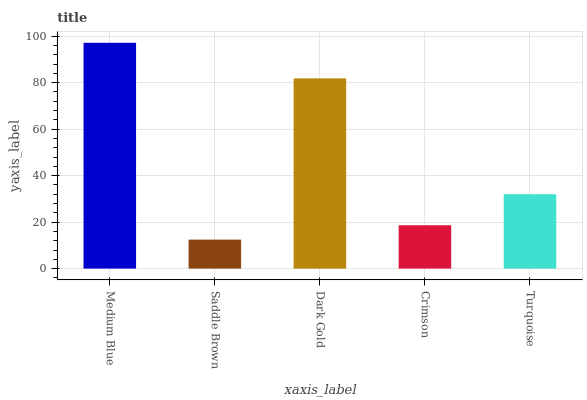Is Saddle Brown the minimum?
Answer yes or no. Yes. Is Medium Blue the maximum?
Answer yes or no. Yes. Is Dark Gold the minimum?
Answer yes or no. No. Is Dark Gold the maximum?
Answer yes or no. No. Is Dark Gold greater than Saddle Brown?
Answer yes or no. Yes. Is Saddle Brown less than Dark Gold?
Answer yes or no. Yes. Is Saddle Brown greater than Dark Gold?
Answer yes or no. No. Is Dark Gold less than Saddle Brown?
Answer yes or no. No. Is Turquoise the high median?
Answer yes or no. Yes. Is Turquoise the low median?
Answer yes or no. Yes. Is Medium Blue the high median?
Answer yes or no. No. Is Medium Blue the low median?
Answer yes or no. No. 